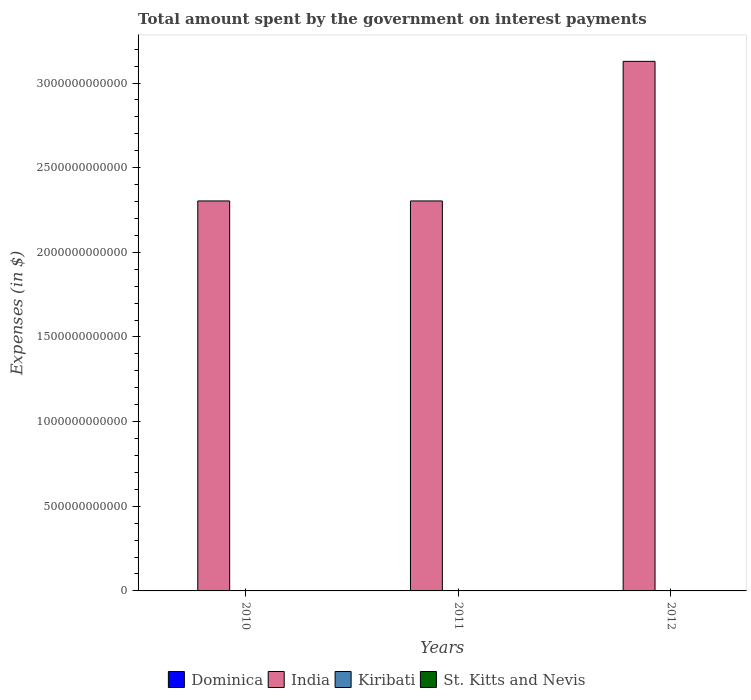How many different coloured bars are there?
Provide a succinct answer. 4. How many groups of bars are there?
Offer a terse response. 3. Are the number of bars per tick equal to the number of legend labels?
Make the answer very short. Yes. Are the number of bars on each tick of the X-axis equal?
Your answer should be very brief. Yes. How many bars are there on the 2nd tick from the left?
Offer a terse response. 4. What is the amount spent on interest payments by the government in Dominica in 2012?
Keep it short and to the point. 4.33e+07. Across all years, what is the maximum amount spent on interest payments by the government in Kiribati?
Keep it short and to the point. 6.19e+06. Across all years, what is the minimum amount spent on interest payments by the government in Dominica?
Make the answer very short. 2.10e+07. In which year was the amount spent on interest payments by the government in St. Kitts and Nevis maximum?
Offer a very short reply. 2010. In which year was the amount spent on interest payments by the government in India minimum?
Provide a short and direct response. 2010. What is the total amount spent on interest payments by the government in Dominica in the graph?
Your answer should be very brief. 8.89e+07. What is the difference between the amount spent on interest payments by the government in St. Kitts and Nevis in 2011 and the amount spent on interest payments by the government in Dominica in 2012?
Offer a terse response. 8.25e+07. What is the average amount spent on interest payments by the government in St. Kitts and Nevis per year?
Ensure brevity in your answer.  1.24e+08. In the year 2012, what is the difference between the amount spent on interest payments by the government in India and amount spent on interest payments by the government in Dominica?
Provide a succinct answer. 3.13e+12. In how many years, is the amount spent on interest payments by the government in St. Kitts and Nevis greater than 1300000000000 $?
Keep it short and to the point. 0. What is the difference between the highest and the second highest amount spent on interest payments by the government in St. Kitts and Nevis?
Provide a short and direct response. 5.20e+06. What is the difference between the highest and the lowest amount spent on interest payments by the government in Kiribati?
Your answer should be very brief. 4.76e+06. In how many years, is the amount spent on interest payments by the government in Kiribati greater than the average amount spent on interest payments by the government in Kiribati taken over all years?
Offer a very short reply. 1. Is the sum of the amount spent on interest payments by the government in St. Kitts and Nevis in 2010 and 2012 greater than the maximum amount spent on interest payments by the government in India across all years?
Give a very brief answer. No. Is it the case that in every year, the sum of the amount spent on interest payments by the government in St. Kitts and Nevis and amount spent on interest payments by the government in India is greater than the sum of amount spent on interest payments by the government in Dominica and amount spent on interest payments by the government in Kiribati?
Ensure brevity in your answer.  Yes. What does the 3rd bar from the left in 2011 represents?
Your response must be concise. Kiribati. What does the 4th bar from the right in 2010 represents?
Your response must be concise. Dominica. How many bars are there?
Offer a very short reply. 12. Are all the bars in the graph horizontal?
Your answer should be compact. No. How many years are there in the graph?
Offer a very short reply. 3. What is the difference between two consecutive major ticks on the Y-axis?
Offer a terse response. 5.00e+11. Where does the legend appear in the graph?
Keep it short and to the point. Bottom center. How many legend labels are there?
Your answer should be very brief. 4. How are the legend labels stacked?
Make the answer very short. Horizontal. What is the title of the graph?
Provide a short and direct response. Total amount spent by the government on interest payments. What is the label or title of the Y-axis?
Ensure brevity in your answer.  Expenses (in $). What is the Expenses (in $) in Dominica in 2010?
Your answer should be compact. 2.10e+07. What is the Expenses (in $) in India in 2010?
Give a very brief answer. 2.30e+12. What is the Expenses (in $) in Kiribati in 2010?
Your answer should be very brief. 1.42e+06. What is the Expenses (in $) in St. Kitts and Nevis in 2010?
Provide a short and direct response. 1.31e+08. What is the Expenses (in $) in Dominica in 2011?
Provide a succinct answer. 2.46e+07. What is the Expenses (in $) of India in 2011?
Keep it short and to the point. 2.30e+12. What is the Expenses (in $) of Kiribati in 2011?
Ensure brevity in your answer.  2.66e+06. What is the Expenses (in $) of St. Kitts and Nevis in 2011?
Offer a very short reply. 1.26e+08. What is the Expenses (in $) of Dominica in 2012?
Keep it short and to the point. 4.33e+07. What is the Expenses (in $) in India in 2012?
Your answer should be compact. 3.13e+12. What is the Expenses (in $) of Kiribati in 2012?
Give a very brief answer. 6.19e+06. What is the Expenses (in $) in St. Kitts and Nevis in 2012?
Your answer should be very brief. 1.17e+08. Across all years, what is the maximum Expenses (in $) of Dominica?
Keep it short and to the point. 4.33e+07. Across all years, what is the maximum Expenses (in $) of India?
Give a very brief answer. 3.13e+12. Across all years, what is the maximum Expenses (in $) of Kiribati?
Provide a short and direct response. 6.19e+06. Across all years, what is the maximum Expenses (in $) of St. Kitts and Nevis?
Provide a short and direct response. 1.31e+08. Across all years, what is the minimum Expenses (in $) of Dominica?
Offer a terse response. 2.10e+07. Across all years, what is the minimum Expenses (in $) of India?
Make the answer very short. 2.30e+12. Across all years, what is the minimum Expenses (in $) in Kiribati?
Give a very brief answer. 1.42e+06. Across all years, what is the minimum Expenses (in $) in St. Kitts and Nevis?
Provide a succinct answer. 1.17e+08. What is the total Expenses (in $) of Dominica in the graph?
Give a very brief answer. 8.89e+07. What is the total Expenses (in $) of India in the graph?
Provide a short and direct response. 7.74e+12. What is the total Expenses (in $) in Kiribati in the graph?
Your answer should be compact. 1.03e+07. What is the total Expenses (in $) of St. Kitts and Nevis in the graph?
Your answer should be compact. 3.74e+08. What is the difference between the Expenses (in $) of Dominica in 2010 and that in 2011?
Your answer should be compact. -3.60e+06. What is the difference between the Expenses (in $) in India in 2010 and that in 2011?
Offer a very short reply. 0. What is the difference between the Expenses (in $) in Kiribati in 2010 and that in 2011?
Provide a short and direct response. -1.23e+06. What is the difference between the Expenses (in $) of St. Kitts and Nevis in 2010 and that in 2011?
Keep it short and to the point. 5.20e+06. What is the difference between the Expenses (in $) of Dominica in 2010 and that in 2012?
Offer a terse response. -2.23e+07. What is the difference between the Expenses (in $) in India in 2010 and that in 2012?
Your answer should be compact. -8.25e+11. What is the difference between the Expenses (in $) in Kiribati in 2010 and that in 2012?
Provide a short and direct response. -4.76e+06. What is the difference between the Expenses (in $) of St. Kitts and Nevis in 2010 and that in 2012?
Keep it short and to the point. 1.43e+07. What is the difference between the Expenses (in $) in Dominica in 2011 and that in 2012?
Your answer should be very brief. -1.87e+07. What is the difference between the Expenses (in $) in India in 2011 and that in 2012?
Keep it short and to the point. -8.25e+11. What is the difference between the Expenses (in $) in Kiribati in 2011 and that in 2012?
Offer a terse response. -3.53e+06. What is the difference between the Expenses (in $) in St. Kitts and Nevis in 2011 and that in 2012?
Ensure brevity in your answer.  9.10e+06. What is the difference between the Expenses (in $) of Dominica in 2010 and the Expenses (in $) of India in 2011?
Make the answer very short. -2.30e+12. What is the difference between the Expenses (in $) of Dominica in 2010 and the Expenses (in $) of Kiribati in 2011?
Your answer should be very brief. 1.83e+07. What is the difference between the Expenses (in $) of Dominica in 2010 and the Expenses (in $) of St. Kitts and Nevis in 2011?
Your answer should be compact. -1.05e+08. What is the difference between the Expenses (in $) of India in 2010 and the Expenses (in $) of Kiribati in 2011?
Keep it short and to the point. 2.30e+12. What is the difference between the Expenses (in $) in India in 2010 and the Expenses (in $) in St. Kitts and Nevis in 2011?
Offer a very short reply. 2.30e+12. What is the difference between the Expenses (in $) in Kiribati in 2010 and the Expenses (in $) in St. Kitts and Nevis in 2011?
Provide a short and direct response. -1.24e+08. What is the difference between the Expenses (in $) of Dominica in 2010 and the Expenses (in $) of India in 2012?
Provide a short and direct response. -3.13e+12. What is the difference between the Expenses (in $) in Dominica in 2010 and the Expenses (in $) in Kiribati in 2012?
Provide a succinct answer. 1.48e+07. What is the difference between the Expenses (in $) of Dominica in 2010 and the Expenses (in $) of St. Kitts and Nevis in 2012?
Provide a succinct answer. -9.57e+07. What is the difference between the Expenses (in $) in India in 2010 and the Expenses (in $) in Kiribati in 2012?
Your answer should be very brief. 2.30e+12. What is the difference between the Expenses (in $) of India in 2010 and the Expenses (in $) of St. Kitts and Nevis in 2012?
Provide a succinct answer. 2.30e+12. What is the difference between the Expenses (in $) of Kiribati in 2010 and the Expenses (in $) of St. Kitts and Nevis in 2012?
Offer a very short reply. -1.15e+08. What is the difference between the Expenses (in $) of Dominica in 2011 and the Expenses (in $) of India in 2012?
Ensure brevity in your answer.  -3.13e+12. What is the difference between the Expenses (in $) of Dominica in 2011 and the Expenses (in $) of Kiribati in 2012?
Give a very brief answer. 1.84e+07. What is the difference between the Expenses (in $) in Dominica in 2011 and the Expenses (in $) in St. Kitts and Nevis in 2012?
Your answer should be very brief. -9.21e+07. What is the difference between the Expenses (in $) in India in 2011 and the Expenses (in $) in Kiribati in 2012?
Offer a terse response. 2.30e+12. What is the difference between the Expenses (in $) of India in 2011 and the Expenses (in $) of St. Kitts and Nevis in 2012?
Provide a succinct answer. 2.30e+12. What is the difference between the Expenses (in $) in Kiribati in 2011 and the Expenses (in $) in St. Kitts and Nevis in 2012?
Your answer should be very brief. -1.14e+08. What is the average Expenses (in $) in Dominica per year?
Offer a terse response. 2.96e+07. What is the average Expenses (in $) in India per year?
Offer a very short reply. 2.58e+12. What is the average Expenses (in $) in Kiribati per year?
Ensure brevity in your answer.  3.42e+06. What is the average Expenses (in $) of St. Kitts and Nevis per year?
Provide a succinct answer. 1.24e+08. In the year 2010, what is the difference between the Expenses (in $) of Dominica and Expenses (in $) of India?
Your response must be concise. -2.30e+12. In the year 2010, what is the difference between the Expenses (in $) of Dominica and Expenses (in $) of Kiribati?
Ensure brevity in your answer.  1.96e+07. In the year 2010, what is the difference between the Expenses (in $) of Dominica and Expenses (in $) of St. Kitts and Nevis?
Offer a very short reply. -1.10e+08. In the year 2010, what is the difference between the Expenses (in $) of India and Expenses (in $) of Kiribati?
Provide a short and direct response. 2.30e+12. In the year 2010, what is the difference between the Expenses (in $) of India and Expenses (in $) of St. Kitts and Nevis?
Give a very brief answer. 2.30e+12. In the year 2010, what is the difference between the Expenses (in $) of Kiribati and Expenses (in $) of St. Kitts and Nevis?
Your response must be concise. -1.30e+08. In the year 2011, what is the difference between the Expenses (in $) in Dominica and Expenses (in $) in India?
Ensure brevity in your answer.  -2.30e+12. In the year 2011, what is the difference between the Expenses (in $) of Dominica and Expenses (in $) of Kiribati?
Offer a very short reply. 2.19e+07. In the year 2011, what is the difference between the Expenses (in $) of Dominica and Expenses (in $) of St. Kitts and Nevis?
Your response must be concise. -1.01e+08. In the year 2011, what is the difference between the Expenses (in $) of India and Expenses (in $) of Kiribati?
Provide a succinct answer. 2.30e+12. In the year 2011, what is the difference between the Expenses (in $) in India and Expenses (in $) in St. Kitts and Nevis?
Give a very brief answer. 2.30e+12. In the year 2011, what is the difference between the Expenses (in $) in Kiribati and Expenses (in $) in St. Kitts and Nevis?
Provide a succinct answer. -1.23e+08. In the year 2012, what is the difference between the Expenses (in $) in Dominica and Expenses (in $) in India?
Make the answer very short. -3.13e+12. In the year 2012, what is the difference between the Expenses (in $) of Dominica and Expenses (in $) of Kiribati?
Provide a short and direct response. 3.71e+07. In the year 2012, what is the difference between the Expenses (in $) of Dominica and Expenses (in $) of St. Kitts and Nevis?
Offer a very short reply. -7.34e+07. In the year 2012, what is the difference between the Expenses (in $) in India and Expenses (in $) in Kiribati?
Keep it short and to the point. 3.13e+12. In the year 2012, what is the difference between the Expenses (in $) of India and Expenses (in $) of St. Kitts and Nevis?
Keep it short and to the point. 3.13e+12. In the year 2012, what is the difference between the Expenses (in $) of Kiribati and Expenses (in $) of St. Kitts and Nevis?
Ensure brevity in your answer.  -1.11e+08. What is the ratio of the Expenses (in $) in Dominica in 2010 to that in 2011?
Provide a short and direct response. 0.85. What is the ratio of the Expenses (in $) in India in 2010 to that in 2011?
Give a very brief answer. 1. What is the ratio of the Expenses (in $) in Kiribati in 2010 to that in 2011?
Give a very brief answer. 0.54. What is the ratio of the Expenses (in $) of St. Kitts and Nevis in 2010 to that in 2011?
Provide a succinct answer. 1.04. What is the ratio of the Expenses (in $) of Dominica in 2010 to that in 2012?
Your answer should be very brief. 0.48. What is the ratio of the Expenses (in $) of India in 2010 to that in 2012?
Provide a succinct answer. 0.74. What is the ratio of the Expenses (in $) in Kiribati in 2010 to that in 2012?
Provide a succinct answer. 0.23. What is the ratio of the Expenses (in $) of St. Kitts and Nevis in 2010 to that in 2012?
Your response must be concise. 1.12. What is the ratio of the Expenses (in $) of Dominica in 2011 to that in 2012?
Ensure brevity in your answer.  0.57. What is the ratio of the Expenses (in $) in India in 2011 to that in 2012?
Give a very brief answer. 0.74. What is the ratio of the Expenses (in $) of Kiribati in 2011 to that in 2012?
Give a very brief answer. 0.43. What is the ratio of the Expenses (in $) in St. Kitts and Nevis in 2011 to that in 2012?
Keep it short and to the point. 1.08. What is the difference between the highest and the second highest Expenses (in $) of Dominica?
Make the answer very short. 1.87e+07. What is the difference between the highest and the second highest Expenses (in $) in India?
Your answer should be compact. 8.25e+11. What is the difference between the highest and the second highest Expenses (in $) in Kiribati?
Offer a terse response. 3.53e+06. What is the difference between the highest and the second highest Expenses (in $) in St. Kitts and Nevis?
Provide a succinct answer. 5.20e+06. What is the difference between the highest and the lowest Expenses (in $) in Dominica?
Your answer should be very brief. 2.23e+07. What is the difference between the highest and the lowest Expenses (in $) of India?
Ensure brevity in your answer.  8.25e+11. What is the difference between the highest and the lowest Expenses (in $) of Kiribati?
Ensure brevity in your answer.  4.76e+06. What is the difference between the highest and the lowest Expenses (in $) of St. Kitts and Nevis?
Provide a short and direct response. 1.43e+07. 